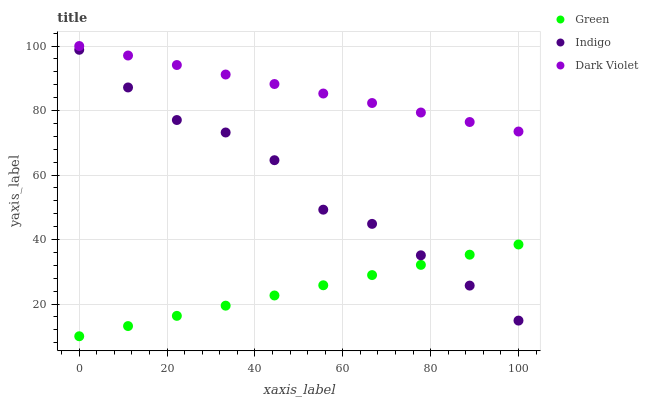Does Green have the minimum area under the curve?
Answer yes or no. Yes. Does Dark Violet have the maximum area under the curve?
Answer yes or no. Yes. Does Dark Violet have the minimum area under the curve?
Answer yes or no. No. Does Green have the maximum area under the curve?
Answer yes or no. No. Is Green the smoothest?
Answer yes or no. Yes. Is Indigo the roughest?
Answer yes or no. Yes. Is Dark Violet the smoothest?
Answer yes or no. No. Is Dark Violet the roughest?
Answer yes or no. No. Does Green have the lowest value?
Answer yes or no. Yes. Does Dark Violet have the lowest value?
Answer yes or no. No. Does Dark Violet have the highest value?
Answer yes or no. Yes. Does Green have the highest value?
Answer yes or no. No. Is Green less than Dark Violet?
Answer yes or no. Yes. Is Dark Violet greater than Indigo?
Answer yes or no. Yes. Does Green intersect Indigo?
Answer yes or no. Yes. Is Green less than Indigo?
Answer yes or no. No. Is Green greater than Indigo?
Answer yes or no. No. Does Green intersect Dark Violet?
Answer yes or no. No. 